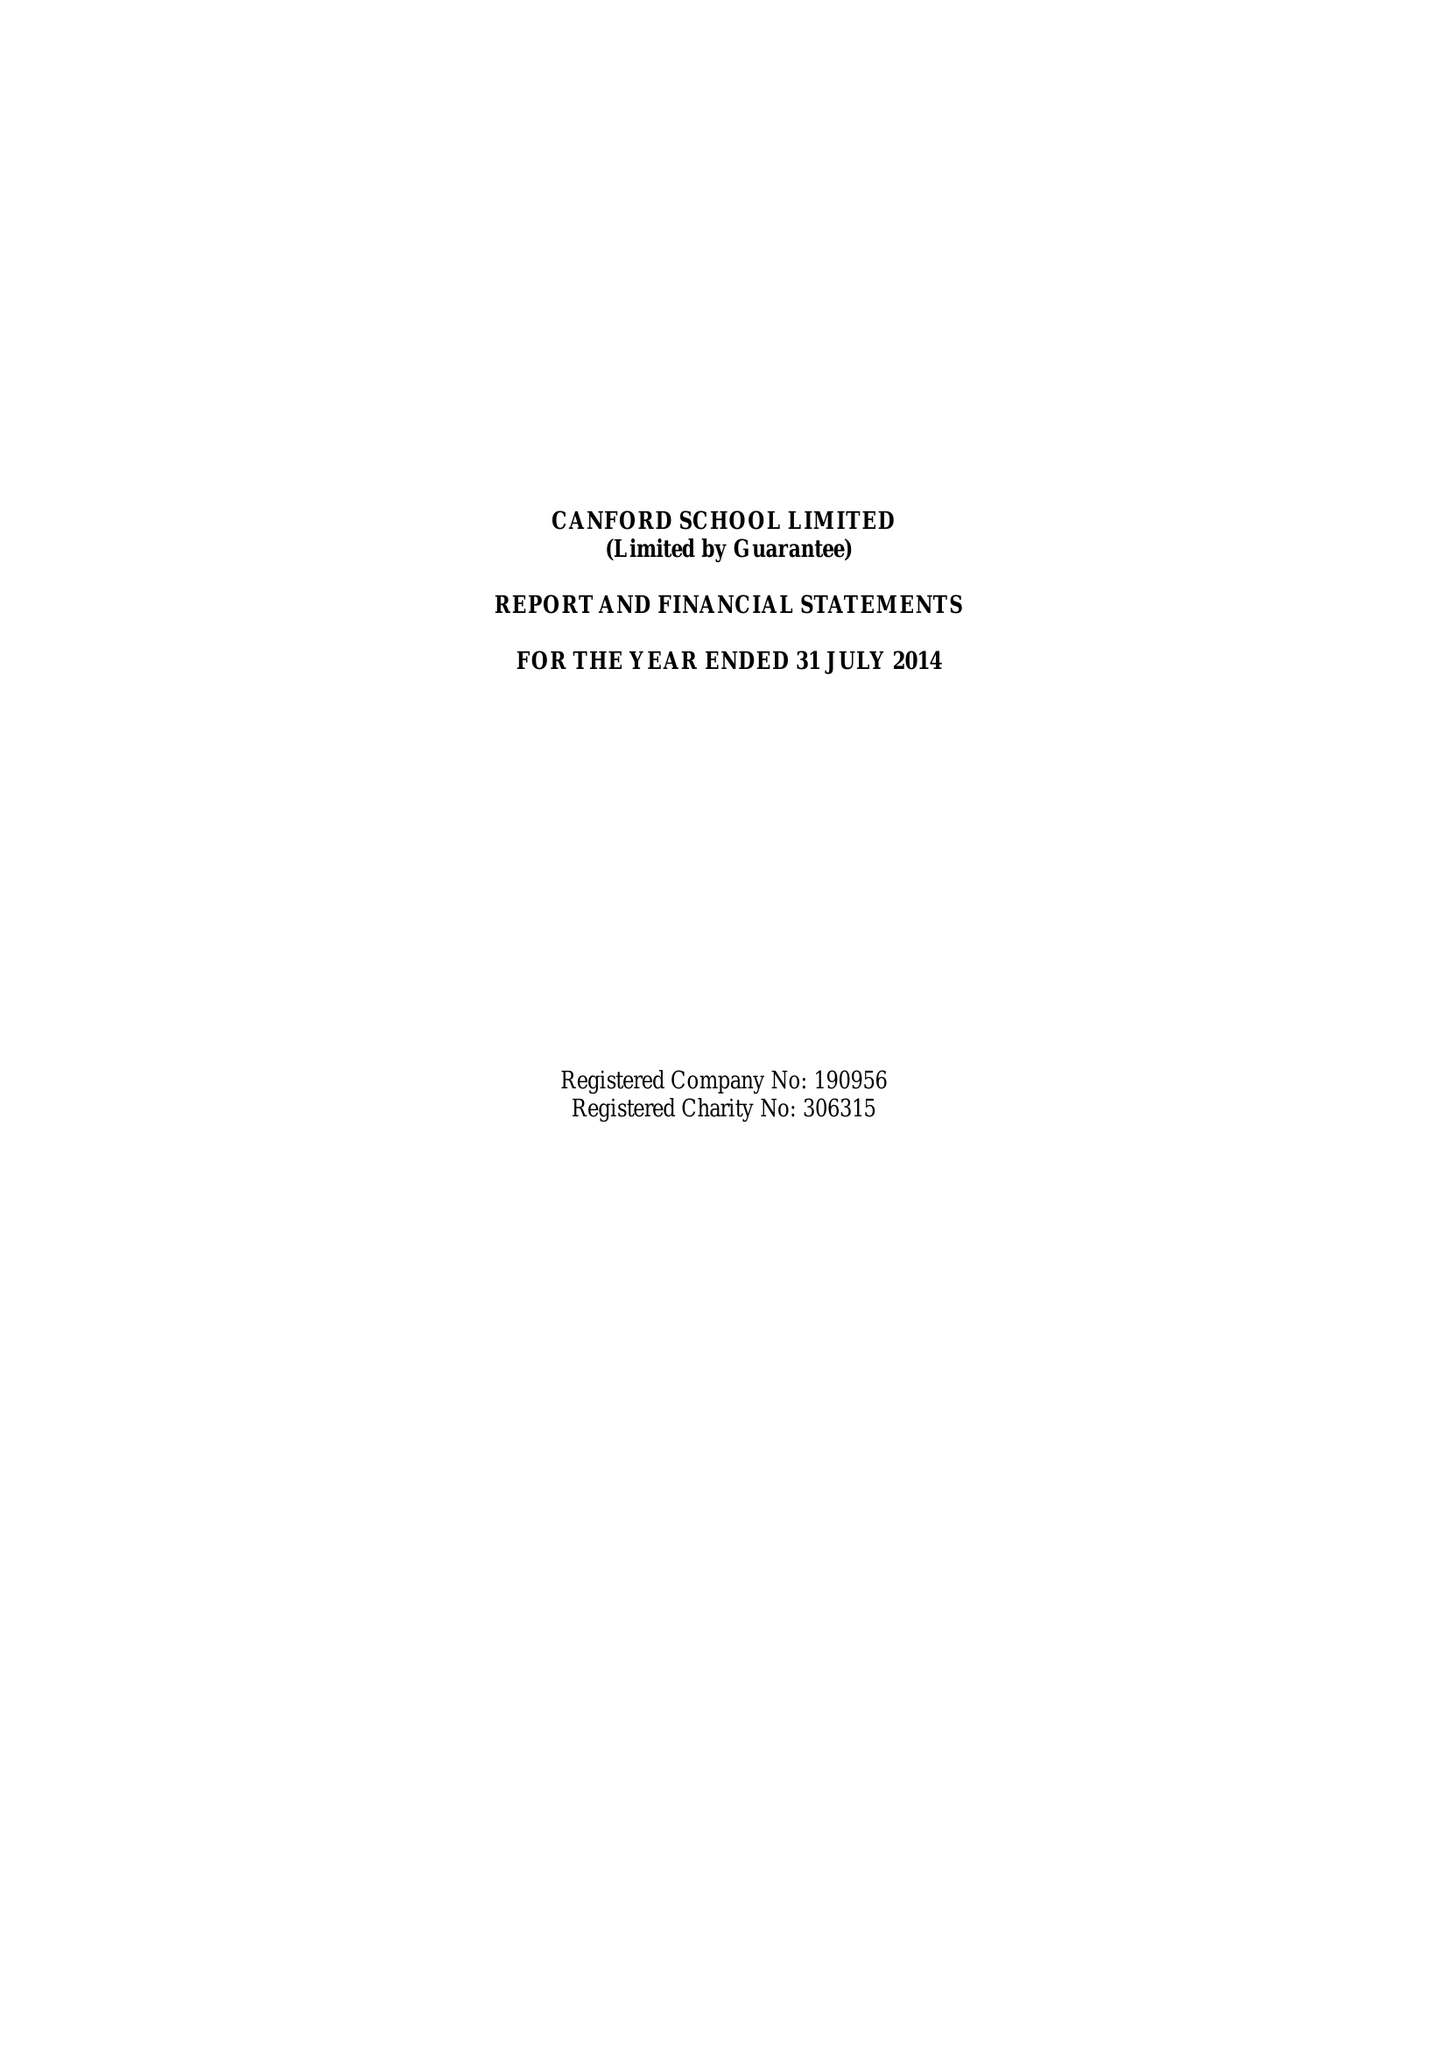What is the value for the address__street_line?
Answer the question using a single word or phrase. CANFORD MAGNA 